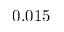Convert formula to latex. <formula><loc_0><loc_0><loc_500><loc_500>0 . 0 1 5</formula> 